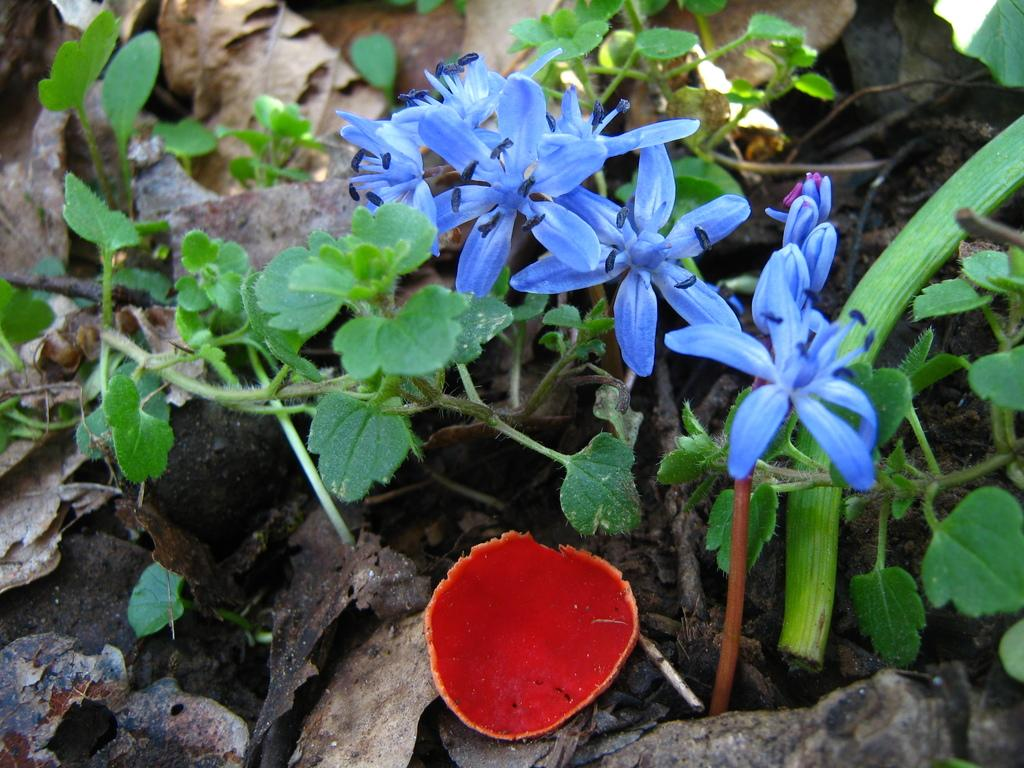What type of plant is present in the image? There is a small plant with violet flowers in the image. What is the color of the substance in the image? There is a red-colored substance with water in the image. What type of rifle can be seen in the image? There is no rifle present in the image. What relation does the plant have with the red-colored substance in the image? The image does not provide any information about the relationship between the plant and the red-colored substance. 